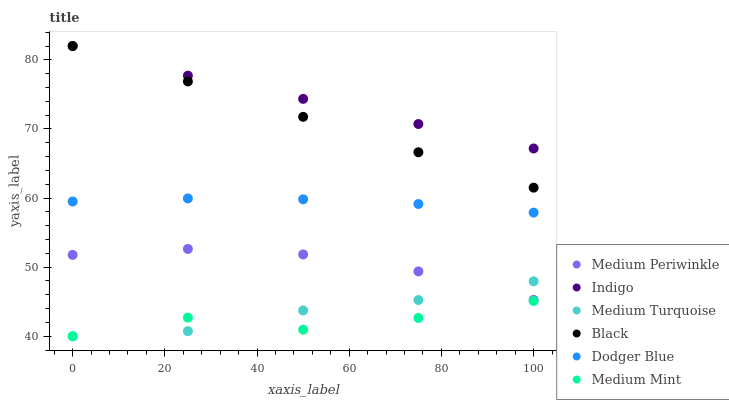Does Medium Mint have the minimum area under the curve?
Answer yes or no. Yes. Does Indigo have the maximum area under the curve?
Answer yes or no. Yes. Does Medium Periwinkle have the minimum area under the curve?
Answer yes or no. No. Does Medium Periwinkle have the maximum area under the curve?
Answer yes or no. No. Is Black the smoothest?
Answer yes or no. Yes. Is Medium Mint the roughest?
Answer yes or no. Yes. Is Indigo the smoothest?
Answer yes or no. No. Is Indigo the roughest?
Answer yes or no. No. Does Medium Mint have the lowest value?
Answer yes or no. Yes. Does Medium Periwinkle have the lowest value?
Answer yes or no. No. Does Black have the highest value?
Answer yes or no. Yes. Does Medium Periwinkle have the highest value?
Answer yes or no. No. Is Medium Turquoise less than Indigo?
Answer yes or no. Yes. Is Medium Periwinkle greater than Medium Mint?
Answer yes or no. Yes. Does Medium Turquoise intersect Medium Mint?
Answer yes or no. Yes. Is Medium Turquoise less than Medium Mint?
Answer yes or no. No. Is Medium Turquoise greater than Medium Mint?
Answer yes or no. No. Does Medium Turquoise intersect Indigo?
Answer yes or no. No. 